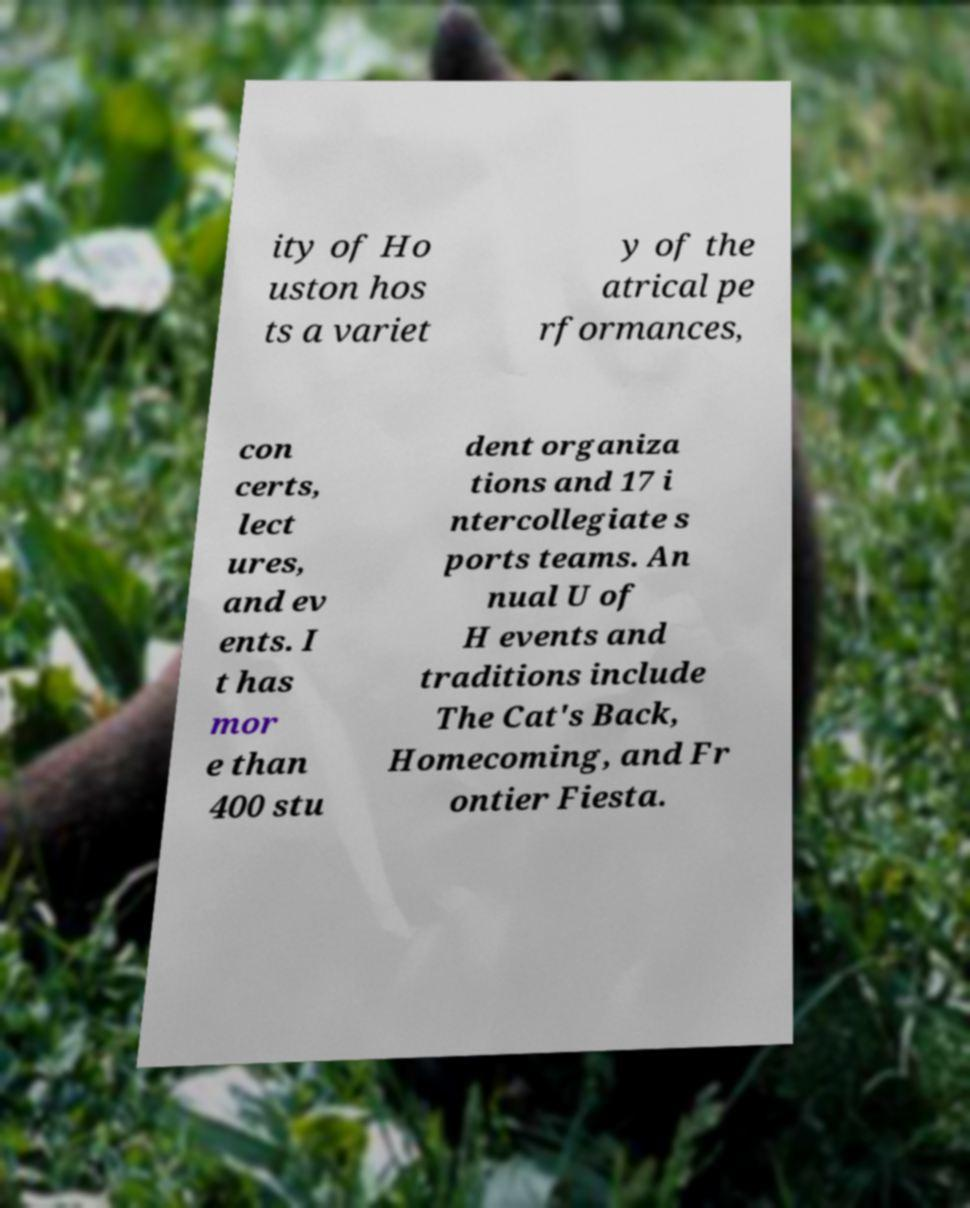Please identify and transcribe the text found in this image. ity of Ho uston hos ts a variet y of the atrical pe rformances, con certs, lect ures, and ev ents. I t has mor e than 400 stu dent organiza tions and 17 i ntercollegiate s ports teams. An nual U of H events and traditions include The Cat's Back, Homecoming, and Fr ontier Fiesta. 